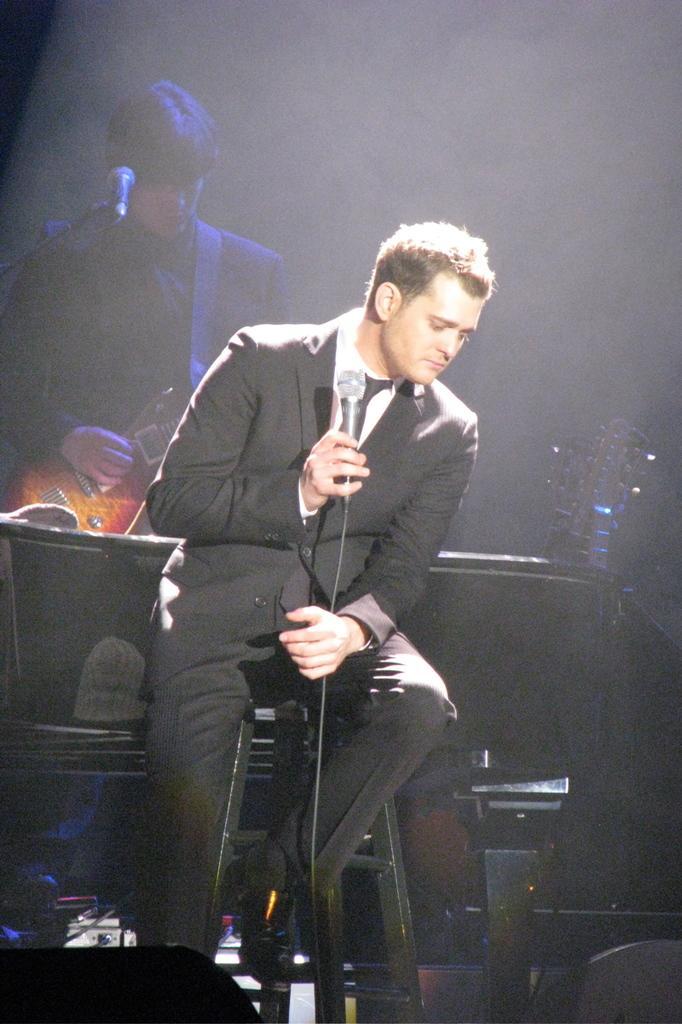Can you describe this image briefly? It is a music concert a person wearing black color coat is sitting on the chair and holding a mike in his hand another person who is standing behind him is holding the guitar in the background it is black and dark. 